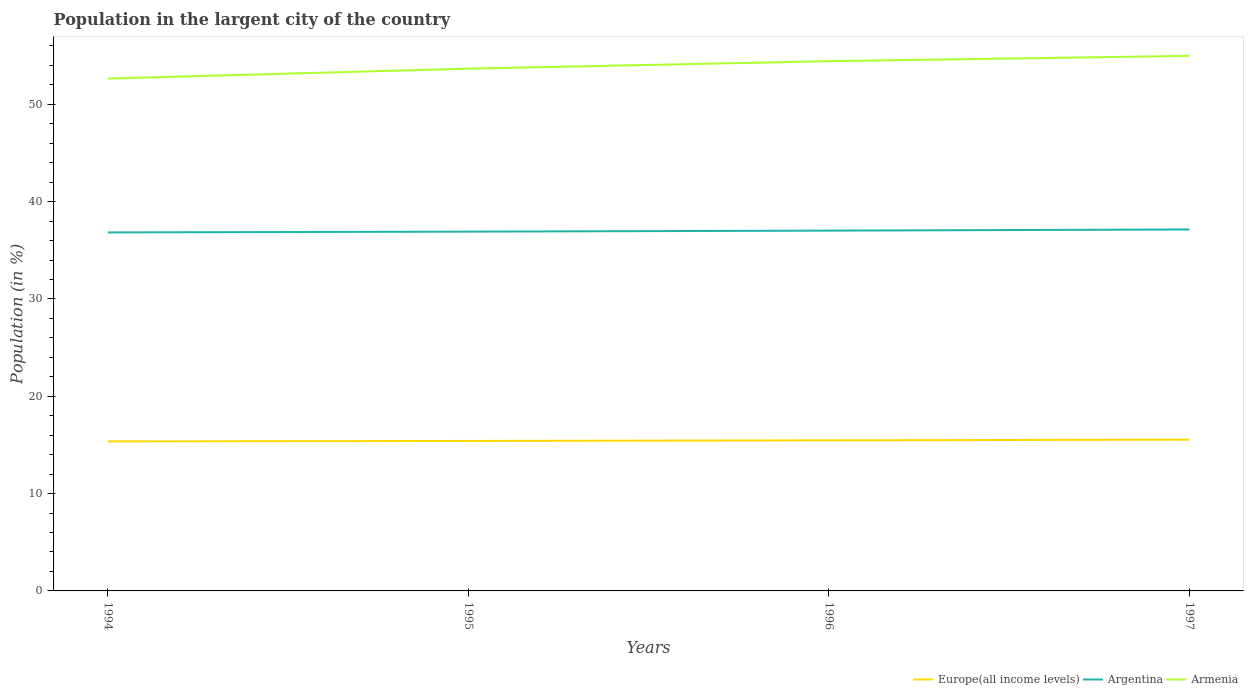Does the line corresponding to Armenia intersect with the line corresponding to Europe(all income levels)?
Make the answer very short. No. Is the number of lines equal to the number of legend labels?
Offer a very short reply. Yes. Across all years, what is the maximum percentage of population in the largent city in Europe(all income levels)?
Offer a very short reply. 15.36. In which year was the percentage of population in the largent city in Europe(all income levels) maximum?
Your answer should be compact. 1994. What is the total percentage of population in the largent city in Armenia in the graph?
Keep it short and to the point. -0.55. What is the difference between the highest and the second highest percentage of population in the largent city in Europe(all income levels)?
Offer a very short reply. 0.18. Is the percentage of population in the largent city in Armenia strictly greater than the percentage of population in the largent city in Argentina over the years?
Offer a very short reply. No. How many years are there in the graph?
Your answer should be compact. 4. Does the graph contain any zero values?
Provide a short and direct response. No. Where does the legend appear in the graph?
Give a very brief answer. Bottom right. How are the legend labels stacked?
Give a very brief answer. Horizontal. What is the title of the graph?
Ensure brevity in your answer.  Population in the largent city of the country. Does "Europe(all income levels)" appear as one of the legend labels in the graph?
Your response must be concise. Yes. What is the Population (in %) in Europe(all income levels) in 1994?
Give a very brief answer. 15.36. What is the Population (in %) in Argentina in 1994?
Your answer should be compact. 36.83. What is the Population (in %) of Armenia in 1994?
Provide a succinct answer. 52.64. What is the Population (in %) of Europe(all income levels) in 1995?
Ensure brevity in your answer.  15.41. What is the Population (in %) in Argentina in 1995?
Your answer should be compact. 36.92. What is the Population (in %) of Armenia in 1995?
Your answer should be compact. 53.66. What is the Population (in %) in Europe(all income levels) in 1996?
Give a very brief answer. 15.47. What is the Population (in %) of Argentina in 1996?
Offer a very short reply. 37.02. What is the Population (in %) in Armenia in 1996?
Provide a short and direct response. 54.43. What is the Population (in %) of Europe(all income levels) in 1997?
Your response must be concise. 15.54. What is the Population (in %) in Argentina in 1997?
Make the answer very short. 37.14. What is the Population (in %) of Armenia in 1997?
Make the answer very short. 54.98. Across all years, what is the maximum Population (in %) in Europe(all income levels)?
Offer a very short reply. 15.54. Across all years, what is the maximum Population (in %) in Argentina?
Your answer should be very brief. 37.14. Across all years, what is the maximum Population (in %) in Armenia?
Make the answer very short. 54.98. Across all years, what is the minimum Population (in %) in Europe(all income levels)?
Your response must be concise. 15.36. Across all years, what is the minimum Population (in %) of Argentina?
Give a very brief answer. 36.83. Across all years, what is the minimum Population (in %) in Armenia?
Keep it short and to the point. 52.64. What is the total Population (in %) of Europe(all income levels) in the graph?
Ensure brevity in your answer.  61.78. What is the total Population (in %) of Argentina in the graph?
Your answer should be very brief. 147.9. What is the total Population (in %) in Armenia in the graph?
Provide a succinct answer. 215.7. What is the difference between the Population (in %) in Europe(all income levels) in 1994 and that in 1995?
Provide a short and direct response. -0.05. What is the difference between the Population (in %) in Argentina in 1994 and that in 1995?
Your answer should be compact. -0.08. What is the difference between the Population (in %) of Armenia in 1994 and that in 1995?
Provide a short and direct response. -1.02. What is the difference between the Population (in %) in Europe(all income levels) in 1994 and that in 1996?
Ensure brevity in your answer.  -0.11. What is the difference between the Population (in %) in Argentina in 1994 and that in 1996?
Ensure brevity in your answer.  -0.18. What is the difference between the Population (in %) in Armenia in 1994 and that in 1996?
Your response must be concise. -1.78. What is the difference between the Population (in %) in Europe(all income levels) in 1994 and that in 1997?
Your answer should be compact. -0.18. What is the difference between the Population (in %) of Argentina in 1994 and that in 1997?
Provide a short and direct response. -0.3. What is the difference between the Population (in %) of Armenia in 1994 and that in 1997?
Your answer should be compact. -2.33. What is the difference between the Population (in %) in Europe(all income levels) in 1995 and that in 1996?
Your response must be concise. -0.06. What is the difference between the Population (in %) of Argentina in 1995 and that in 1996?
Offer a very short reply. -0.1. What is the difference between the Population (in %) in Armenia in 1995 and that in 1996?
Ensure brevity in your answer.  -0.77. What is the difference between the Population (in %) in Europe(all income levels) in 1995 and that in 1997?
Offer a terse response. -0.13. What is the difference between the Population (in %) of Argentina in 1995 and that in 1997?
Your answer should be very brief. -0.22. What is the difference between the Population (in %) in Armenia in 1995 and that in 1997?
Provide a succinct answer. -1.32. What is the difference between the Population (in %) in Europe(all income levels) in 1996 and that in 1997?
Give a very brief answer. -0.07. What is the difference between the Population (in %) of Argentina in 1996 and that in 1997?
Provide a succinct answer. -0.12. What is the difference between the Population (in %) of Armenia in 1996 and that in 1997?
Your answer should be very brief. -0.55. What is the difference between the Population (in %) of Europe(all income levels) in 1994 and the Population (in %) of Argentina in 1995?
Offer a very short reply. -21.55. What is the difference between the Population (in %) in Europe(all income levels) in 1994 and the Population (in %) in Armenia in 1995?
Your response must be concise. -38.3. What is the difference between the Population (in %) in Argentina in 1994 and the Population (in %) in Armenia in 1995?
Offer a very short reply. -16.83. What is the difference between the Population (in %) of Europe(all income levels) in 1994 and the Population (in %) of Argentina in 1996?
Offer a very short reply. -21.66. What is the difference between the Population (in %) in Europe(all income levels) in 1994 and the Population (in %) in Armenia in 1996?
Ensure brevity in your answer.  -39.07. What is the difference between the Population (in %) in Argentina in 1994 and the Population (in %) in Armenia in 1996?
Provide a succinct answer. -17.59. What is the difference between the Population (in %) of Europe(all income levels) in 1994 and the Population (in %) of Argentina in 1997?
Offer a very short reply. -21.78. What is the difference between the Population (in %) in Europe(all income levels) in 1994 and the Population (in %) in Armenia in 1997?
Provide a succinct answer. -39.61. What is the difference between the Population (in %) of Argentina in 1994 and the Population (in %) of Armenia in 1997?
Keep it short and to the point. -18.14. What is the difference between the Population (in %) in Europe(all income levels) in 1995 and the Population (in %) in Argentina in 1996?
Keep it short and to the point. -21.61. What is the difference between the Population (in %) of Europe(all income levels) in 1995 and the Population (in %) of Armenia in 1996?
Give a very brief answer. -39.02. What is the difference between the Population (in %) of Argentina in 1995 and the Population (in %) of Armenia in 1996?
Provide a succinct answer. -17.51. What is the difference between the Population (in %) in Europe(all income levels) in 1995 and the Population (in %) in Argentina in 1997?
Offer a terse response. -21.73. What is the difference between the Population (in %) of Europe(all income levels) in 1995 and the Population (in %) of Armenia in 1997?
Ensure brevity in your answer.  -39.57. What is the difference between the Population (in %) of Argentina in 1995 and the Population (in %) of Armenia in 1997?
Your answer should be compact. -18.06. What is the difference between the Population (in %) of Europe(all income levels) in 1996 and the Population (in %) of Argentina in 1997?
Keep it short and to the point. -21.66. What is the difference between the Population (in %) in Europe(all income levels) in 1996 and the Population (in %) in Armenia in 1997?
Provide a short and direct response. -39.5. What is the difference between the Population (in %) in Argentina in 1996 and the Population (in %) in Armenia in 1997?
Keep it short and to the point. -17.96. What is the average Population (in %) in Europe(all income levels) per year?
Your response must be concise. 15.45. What is the average Population (in %) in Argentina per year?
Your answer should be compact. 36.98. What is the average Population (in %) of Armenia per year?
Your answer should be compact. 53.93. In the year 1994, what is the difference between the Population (in %) of Europe(all income levels) and Population (in %) of Argentina?
Keep it short and to the point. -21.47. In the year 1994, what is the difference between the Population (in %) in Europe(all income levels) and Population (in %) in Armenia?
Ensure brevity in your answer.  -37.28. In the year 1994, what is the difference between the Population (in %) of Argentina and Population (in %) of Armenia?
Your answer should be very brief. -15.81. In the year 1995, what is the difference between the Population (in %) of Europe(all income levels) and Population (in %) of Argentina?
Provide a succinct answer. -21.51. In the year 1995, what is the difference between the Population (in %) in Europe(all income levels) and Population (in %) in Armenia?
Provide a succinct answer. -38.25. In the year 1995, what is the difference between the Population (in %) of Argentina and Population (in %) of Armenia?
Your answer should be compact. -16.74. In the year 1996, what is the difference between the Population (in %) of Europe(all income levels) and Population (in %) of Argentina?
Make the answer very short. -21.55. In the year 1996, what is the difference between the Population (in %) in Europe(all income levels) and Population (in %) in Armenia?
Provide a short and direct response. -38.95. In the year 1996, what is the difference between the Population (in %) of Argentina and Population (in %) of Armenia?
Give a very brief answer. -17.41. In the year 1997, what is the difference between the Population (in %) of Europe(all income levels) and Population (in %) of Argentina?
Make the answer very short. -21.6. In the year 1997, what is the difference between the Population (in %) in Europe(all income levels) and Population (in %) in Armenia?
Make the answer very short. -39.43. In the year 1997, what is the difference between the Population (in %) in Argentina and Population (in %) in Armenia?
Ensure brevity in your answer.  -17.84. What is the ratio of the Population (in %) in Europe(all income levels) in 1994 to that in 1995?
Make the answer very short. 1. What is the ratio of the Population (in %) in Armenia in 1994 to that in 1995?
Ensure brevity in your answer.  0.98. What is the ratio of the Population (in %) in Argentina in 1994 to that in 1996?
Provide a succinct answer. 0.99. What is the ratio of the Population (in %) in Armenia in 1994 to that in 1996?
Your answer should be very brief. 0.97. What is the ratio of the Population (in %) in Europe(all income levels) in 1994 to that in 1997?
Your answer should be very brief. 0.99. What is the ratio of the Population (in %) in Argentina in 1994 to that in 1997?
Give a very brief answer. 0.99. What is the ratio of the Population (in %) in Armenia in 1994 to that in 1997?
Your response must be concise. 0.96. What is the ratio of the Population (in %) in Argentina in 1995 to that in 1996?
Make the answer very short. 1. What is the ratio of the Population (in %) in Armenia in 1995 to that in 1996?
Provide a short and direct response. 0.99. What is the ratio of the Population (in %) of Armenia in 1995 to that in 1997?
Provide a succinct answer. 0.98. What is the ratio of the Population (in %) in Argentina in 1996 to that in 1997?
Offer a very short reply. 1. What is the difference between the highest and the second highest Population (in %) in Europe(all income levels)?
Provide a short and direct response. 0.07. What is the difference between the highest and the second highest Population (in %) in Argentina?
Give a very brief answer. 0.12. What is the difference between the highest and the second highest Population (in %) in Armenia?
Keep it short and to the point. 0.55. What is the difference between the highest and the lowest Population (in %) in Europe(all income levels)?
Offer a very short reply. 0.18. What is the difference between the highest and the lowest Population (in %) in Argentina?
Make the answer very short. 0.3. What is the difference between the highest and the lowest Population (in %) in Armenia?
Your response must be concise. 2.33. 